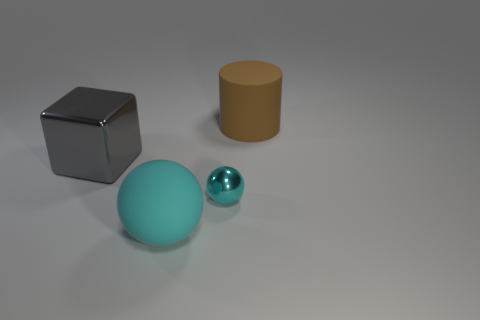Add 4 large cyan objects. How many objects exist? 8 Subtract all cylinders. How many objects are left? 3 Subtract all purple rubber blocks. Subtract all large matte spheres. How many objects are left? 3 Add 4 big gray blocks. How many big gray blocks are left? 5 Add 4 rubber spheres. How many rubber spheres exist? 5 Subtract 0 green spheres. How many objects are left? 4 